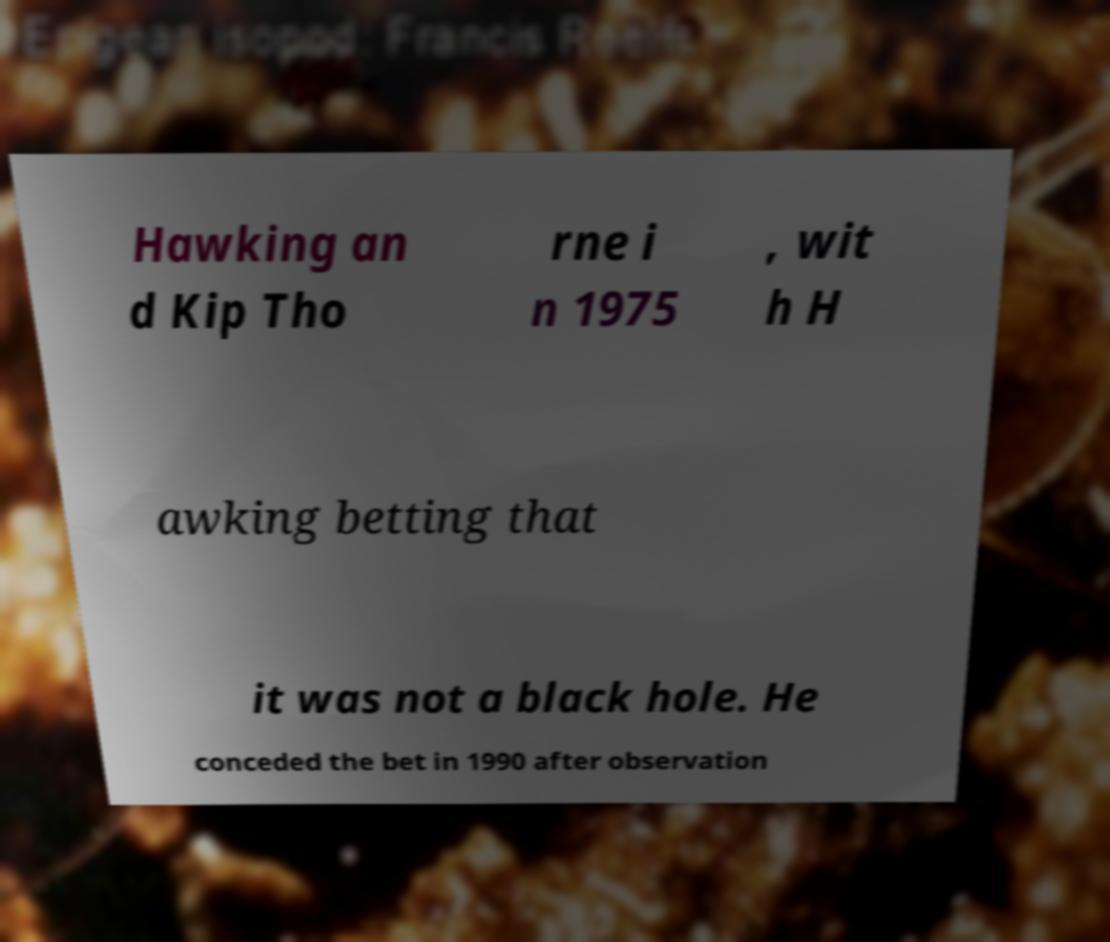Could you extract and type out the text from this image? Hawking an d Kip Tho rne i n 1975 , wit h H awking betting that it was not a black hole. He conceded the bet in 1990 after observation 